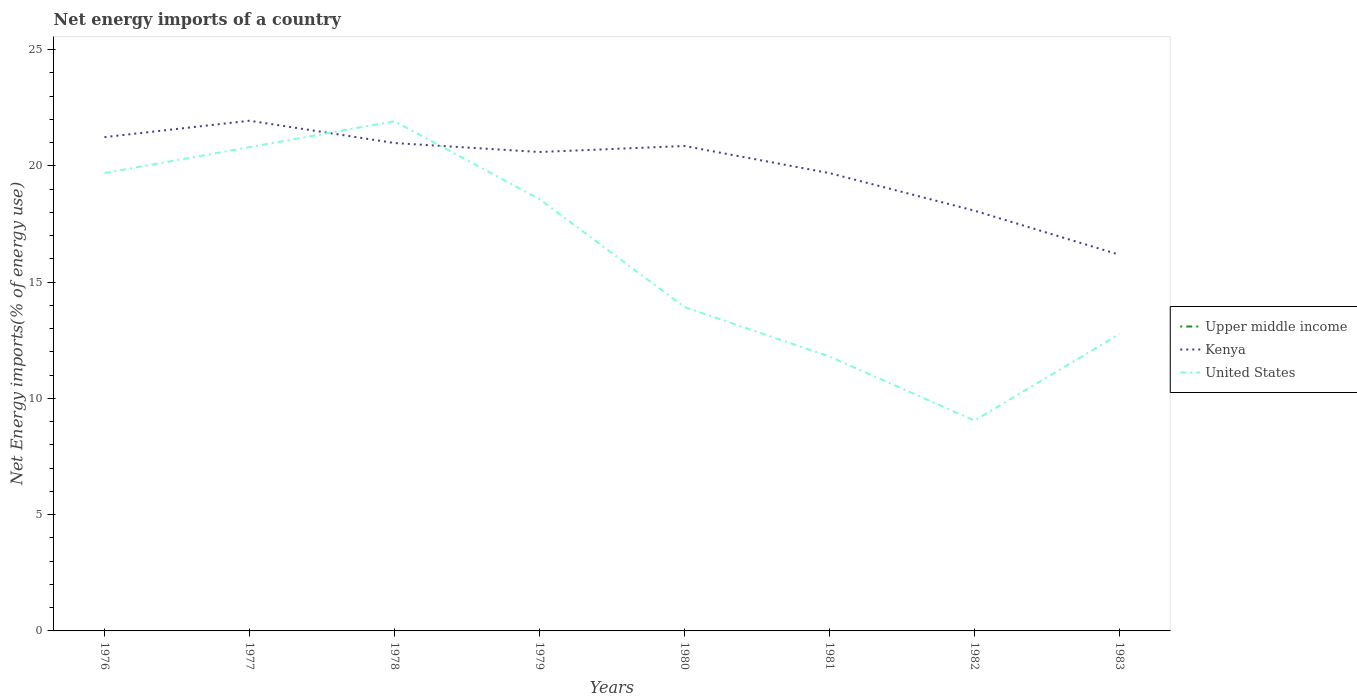Is the number of lines equal to the number of legend labels?
Provide a succinct answer. No. Across all years, what is the maximum net energy imports in United States?
Offer a terse response. 9.05. What is the total net energy imports in Kenya in the graph?
Your answer should be very brief. -0.71. What is the difference between the highest and the second highest net energy imports in United States?
Offer a very short reply. 12.87. What is the difference between the highest and the lowest net energy imports in Upper middle income?
Give a very brief answer. 0. What is the difference between two consecutive major ticks on the Y-axis?
Your response must be concise. 5. Are the values on the major ticks of Y-axis written in scientific E-notation?
Provide a short and direct response. No. Where does the legend appear in the graph?
Offer a very short reply. Center right. How are the legend labels stacked?
Ensure brevity in your answer.  Vertical. What is the title of the graph?
Your answer should be compact. Net energy imports of a country. Does "Venezuela" appear as one of the legend labels in the graph?
Your answer should be very brief. No. What is the label or title of the Y-axis?
Your response must be concise. Net Energy imports(% of energy use). What is the Net Energy imports(% of energy use) in Upper middle income in 1976?
Your answer should be compact. 0. What is the Net Energy imports(% of energy use) in Kenya in 1976?
Provide a succinct answer. 21.24. What is the Net Energy imports(% of energy use) of United States in 1976?
Keep it short and to the point. 19.69. What is the Net Energy imports(% of energy use) in Kenya in 1977?
Your answer should be very brief. 21.95. What is the Net Energy imports(% of energy use) of United States in 1977?
Make the answer very short. 20.81. What is the Net Energy imports(% of energy use) of Upper middle income in 1978?
Ensure brevity in your answer.  0. What is the Net Energy imports(% of energy use) of Kenya in 1978?
Your answer should be very brief. 20.99. What is the Net Energy imports(% of energy use) in United States in 1978?
Offer a terse response. 21.92. What is the Net Energy imports(% of energy use) in Upper middle income in 1979?
Your response must be concise. 0. What is the Net Energy imports(% of energy use) of Kenya in 1979?
Give a very brief answer. 20.6. What is the Net Energy imports(% of energy use) in United States in 1979?
Your response must be concise. 18.57. What is the Net Energy imports(% of energy use) of Kenya in 1980?
Your response must be concise. 20.86. What is the Net Energy imports(% of energy use) in United States in 1980?
Your response must be concise. 13.93. What is the Net Energy imports(% of energy use) in Kenya in 1981?
Provide a short and direct response. 19.69. What is the Net Energy imports(% of energy use) of United States in 1981?
Offer a very short reply. 11.8. What is the Net Energy imports(% of energy use) in Upper middle income in 1982?
Offer a terse response. 0. What is the Net Energy imports(% of energy use) of Kenya in 1982?
Make the answer very short. 18.08. What is the Net Energy imports(% of energy use) in United States in 1982?
Give a very brief answer. 9.05. What is the Net Energy imports(% of energy use) of Kenya in 1983?
Your answer should be very brief. 16.18. What is the Net Energy imports(% of energy use) of United States in 1983?
Offer a very short reply. 12.77. Across all years, what is the maximum Net Energy imports(% of energy use) of Kenya?
Make the answer very short. 21.95. Across all years, what is the maximum Net Energy imports(% of energy use) of United States?
Keep it short and to the point. 21.92. Across all years, what is the minimum Net Energy imports(% of energy use) in Kenya?
Ensure brevity in your answer.  16.18. Across all years, what is the minimum Net Energy imports(% of energy use) in United States?
Offer a very short reply. 9.05. What is the total Net Energy imports(% of energy use) of Kenya in the graph?
Your response must be concise. 159.58. What is the total Net Energy imports(% of energy use) of United States in the graph?
Your response must be concise. 128.55. What is the difference between the Net Energy imports(% of energy use) of Kenya in 1976 and that in 1977?
Your answer should be compact. -0.71. What is the difference between the Net Energy imports(% of energy use) of United States in 1976 and that in 1977?
Offer a terse response. -1.11. What is the difference between the Net Energy imports(% of energy use) of Kenya in 1976 and that in 1978?
Provide a short and direct response. 0.25. What is the difference between the Net Energy imports(% of energy use) of United States in 1976 and that in 1978?
Keep it short and to the point. -2.23. What is the difference between the Net Energy imports(% of energy use) in Kenya in 1976 and that in 1979?
Make the answer very short. 0.64. What is the difference between the Net Energy imports(% of energy use) in United States in 1976 and that in 1979?
Your answer should be very brief. 1.12. What is the difference between the Net Energy imports(% of energy use) in Kenya in 1976 and that in 1980?
Offer a terse response. 0.38. What is the difference between the Net Energy imports(% of energy use) in United States in 1976 and that in 1980?
Ensure brevity in your answer.  5.76. What is the difference between the Net Energy imports(% of energy use) of Kenya in 1976 and that in 1981?
Keep it short and to the point. 1.55. What is the difference between the Net Energy imports(% of energy use) in United States in 1976 and that in 1981?
Your answer should be very brief. 7.89. What is the difference between the Net Energy imports(% of energy use) of Kenya in 1976 and that in 1982?
Your answer should be compact. 3.16. What is the difference between the Net Energy imports(% of energy use) in United States in 1976 and that in 1982?
Make the answer very short. 10.65. What is the difference between the Net Energy imports(% of energy use) in Kenya in 1976 and that in 1983?
Make the answer very short. 5.06. What is the difference between the Net Energy imports(% of energy use) of United States in 1976 and that in 1983?
Provide a short and direct response. 6.92. What is the difference between the Net Energy imports(% of energy use) in Kenya in 1977 and that in 1978?
Provide a short and direct response. 0.96. What is the difference between the Net Energy imports(% of energy use) in United States in 1977 and that in 1978?
Your answer should be compact. -1.12. What is the difference between the Net Energy imports(% of energy use) of Kenya in 1977 and that in 1979?
Keep it short and to the point. 1.35. What is the difference between the Net Energy imports(% of energy use) in United States in 1977 and that in 1979?
Offer a very short reply. 2.23. What is the difference between the Net Energy imports(% of energy use) of Kenya in 1977 and that in 1980?
Provide a succinct answer. 1.09. What is the difference between the Net Energy imports(% of energy use) in United States in 1977 and that in 1980?
Your answer should be compact. 6.88. What is the difference between the Net Energy imports(% of energy use) in Kenya in 1977 and that in 1981?
Provide a succinct answer. 2.25. What is the difference between the Net Energy imports(% of energy use) of United States in 1977 and that in 1981?
Provide a short and direct response. 9.01. What is the difference between the Net Energy imports(% of energy use) in Kenya in 1977 and that in 1982?
Your answer should be very brief. 3.87. What is the difference between the Net Energy imports(% of energy use) of United States in 1977 and that in 1982?
Your answer should be compact. 11.76. What is the difference between the Net Energy imports(% of energy use) of Kenya in 1977 and that in 1983?
Provide a succinct answer. 5.76. What is the difference between the Net Energy imports(% of energy use) of United States in 1977 and that in 1983?
Your answer should be very brief. 8.04. What is the difference between the Net Energy imports(% of energy use) of Kenya in 1978 and that in 1979?
Offer a very short reply. 0.39. What is the difference between the Net Energy imports(% of energy use) in United States in 1978 and that in 1979?
Provide a succinct answer. 3.35. What is the difference between the Net Energy imports(% of energy use) in Kenya in 1978 and that in 1980?
Your answer should be compact. 0.13. What is the difference between the Net Energy imports(% of energy use) of United States in 1978 and that in 1980?
Offer a very short reply. 7.99. What is the difference between the Net Energy imports(% of energy use) of Kenya in 1978 and that in 1981?
Offer a very short reply. 1.29. What is the difference between the Net Energy imports(% of energy use) of United States in 1978 and that in 1981?
Your answer should be very brief. 10.12. What is the difference between the Net Energy imports(% of energy use) of Kenya in 1978 and that in 1982?
Your answer should be very brief. 2.91. What is the difference between the Net Energy imports(% of energy use) of United States in 1978 and that in 1982?
Your answer should be very brief. 12.87. What is the difference between the Net Energy imports(% of energy use) in Kenya in 1978 and that in 1983?
Make the answer very short. 4.81. What is the difference between the Net Energy imports(% of energy use) of United States in 1978 and that in 1983?
Keep it short and to the point. 9.15. What is the difference between the Net Energy imports(% of energy use) in Kenya in 1979 and that in 1980?
Your answer should be compact. -0.26. What is the difference between the Net Energy imports(% of energy use) in United States in 1979 and that in 1980?
Keep it short and to the point. 4.64. What is the difference between the Net Energy imports(% of energy use) of Kenya in 1979 and that in 1981?
Your answer should be compact. 0.91. What is the difference between the Net Energy imports(% of energy use) of United States in 1979 and that in 1981?
Offer a very short reply. 6.77. What is the difference between the Net Energy imports(% of energy use) of Kenya in 1979 and that in 1982?
Your answer should be compact. 2.52. What is the difference between the Net Energy imports(% of energy use) in United States in 1979 and that in 1982?
Your answer should be very brief. 9.53. What is the difference between the Net Energy imports(% of energy use) of Kenya in 1979 and that in 1983?
Keep it short and to the point. 4.42. What is the difference between the Net Energy imports(% of energy use) in United States in 1979 and that in 1983?
Offer a terse response. 5.8. What is the difference between the Net Energy imports(% of energy use) of Kenya in 1980 and that in 1981?
Offer a very short reply. 1.17. What is the difference between the Net Energy imports(% of energy use) in United States in 1980 and that in 1981?
Provide a short and direct response. 2.13. What is the difference between the Net Energy imports(% of energy use) in Kenya in 1980 and that in 1982?
Make the answer very short. 2.78. What is the difference between the Net Energy imports(% of energy use) in United States in 1980 and that in 1982?
Offer a very short reply. 4.88. What is the difference between the Net Energy imports(% of energy use) of Kenya in 1980 and that in 1983?
Your answer should be very brief. 4.68. What is the difference between the Net Energy imports(% of energy use) in United States in 1980 and that in 1983?
Provide a short and direct response. 1.16. What is the difference between the Net Energy imports(% of energy use) of Kenya in 1981 and that in 1982?
Keep it short and to the point. 1.62. What is the difference between the Net Energy imports(% of energy use) in United States in 1981 and that in 1982?
Make the answer very short. 2.75. What is the difference between the Net Energy imports(% of energy use) in Kenya in 1981 and that in 1983?
Offer a very short reply. 3.51. What is the difference between the Net Energy imports(% of energy use) in United States in 1981 and that in 1983?
Your answer should be compact. -0.97. What is the difference between the Net Energy imports(% of energy use) of Kenya in 1982 and that in 1983?
Keep it short and to the point. 1.9. What is the difference between the Net Energy imports(% of energy use) of United States in 1982 and that in 1983?
Keep it short and to the point. -3.72. What is the difference between the Net Energy imports(% of energy use) of Kenya in 1976 and the Net Energy imports(% of energy use) of United States in 1977?
Your answer should be compact. 0.43. What is the difference between the Net Energy imports(% of energy use) of Kenya in 1976 and the Net Energy imports(% of energy use) of United States in 1978?
Provide a short and direct response. -0.68. What is the difference between the Net Energy imports(% of energy use) of Kenya in 1976 and the Net Energy imports(% of energy use) of United States in 1979?
Give a very brief answer. 2.67. What is the difference between the Net Energy imports(% of energy use) of Kenya in 1976 and the Net Energy imports(% of energy use) of United States in 1980?
Your response must be concise. 7.31. What is the difference between the Net Energy imports(% of energy use) of Kenya in 1976 and the Net Energy imports(% of energy use) of United States in 1981?
Keep it short and to the point. 9.44. What is the difference between the Net Energy imports(% of energy use) in Kenya in 1976 and the Net Energy imports(% of energy use) in United States in 1982?
Provide a succinct answer. 12.19. What is the difference between the Net Energy imports(% of energy use) of Kenya in 1976 and the Net Energy imports(% of energy use) of United States in 1983?
Your answer should be very brief. 8.47. What is the difference between the Net Energy imports(% of energy use) of Kenya in 1977 and the Net Energy imports(% of energy use) of United States in 1978?
Ensure brevity in your answer.  0.02. What is the difference between the Net Energy imports(% of energy use) of Kenya in 1977 and the Net Energy imports(% of energy use) of United States in 1979?
Offer a very short reply. 3.37. What is the difference between the Net Energy imports(% of energy use) of Kenya in 1977 and the Net Energy imports(% of energy use) of United States in 1980?
Give a very brief answer. 8.01. What is the difference between the Net Energy imports(% of energy use) of Kenya in 1977 and the Net Energy imports(% of energy use) of United States in 1981?
Offer a very short reply. 10.14. What is the difference between the Net Energy imports(% of energy use) of Kenya in 1977 and the Net Energy imports(% of energy use) of United States in 1982?
Offer a very short reply. 12.9. What is the difference between the Net Energy imports(% of energy use) of Kenya in 1977 and the Net Energy imports(% of energy use) of United States in 1983?
Make the answer very short. 9.17. What is the difference between the Net Energy imports(% of energy use) in Kenya in 1978 and the Net Energy imports(% of energy use) in United States in 1979?
Give a very brief answer. 2.41. What is the difference between the Net Energy imports(% of energy use) in Kenya in 1978 and the Net Energy imports(% of energy use) in United States in 1980?
Your response must be concise. 7.05. What is the difference between the Net Energy imports(% of energy use) in Kenya in 1978 and the Net Energy imports(% of energy use) in United States in 1981?
Ensure brevity in your answer.  9.18. What is the difference between the Net Energy imports(% of energy use) of Kenya in 1978 and the Net Energy imports(% of energy use) of United States in 1982?
Your answer should be very brief. 11.94. What is the difference between the Net Energy imports(% of energy use) of Kenya in 1978 and the Net Energy imports(% of energy use) of United States in 1983?
Give a very brief answer. 8.22. What is the difference between the Net Energy imports(% of energy use) in Kenya in 1979 and the Net Energy imports(% of energy use) in United States in 1980?
Your response must be concise. 6.67. What is the difference between the Net Energy imports(% of energy use) in Kenya in 1979 and the Net Energy imports(% of energy use) in United States in 1981?
Make the answer very short. 8.8. What is the difference between the Net Energy imports(% of energy use) of Kenya in 1979 and the Net Energy imports(% of energy use) of United States in 1982?
Provide a short and direct response. 11.55. What is the difference between the Net Energy imports(% of energy use) in Kenya in 1979 and the Net Energy imports(% of energy use) in United States in 1983?
Ensure brevity in your answer.  7.83. What is the difference between the Net Energy imports(% of energy use) in Kenya in 1980 and the Net Energy imports(% of energy use) in United States in 1981?
Your answer should be compact. 9.06. What is the difference between the Net Energy imports(% of energy use) of Kenya in 1980 and the Net Energy imports(% of energy use) of United States in 1982?
Ensure brevity in your answer.  11.81. What is the difference between the Net Energy imports(% of energy use) in Kenya in 1980 and the Net Energy imports(% of energy use) in United States in 1983?
Provide a short and direct response. 8.09. What is the difference between the Net Energy imports(% of energy use) in Kenya in 1981 and the Net Energy imports(% of energy use) in United States in 1982?
Keep it short and to the point. 10.64. What is the difference between the Net Energy imports(% of energy use) in Kenya in 1981 and the Net Energy imports(% of energy use) in United States in 1983?
Give a very brief answer. 6.92. What is the difference between the Net Energy imports(% of energy use) of Kenya in 1982 and the Net Energy imports(% of energy use) of United States in 1983?
Your answer should be very brief. 5.31. What is the average Net Energy imports(% of energy use) of Upper middle income per year?
Keep it short and to the point. 0. What is the average Net Energy imports(% of energy use) of Kenya per year?
Your answer should be very brief. 19.95. What is the average Net Energy imports(% of energy use) of United States per year?
Provide a succinct answer. 16.07. In the year 1976, what is the difference between the Net Energy imports(% of energy use) in Kenya and Net Energy imports(% of energy use) in United States?
Make the answer very short. 1.55. In the year 1977, what is the difference between the Net Energy imports(% of energy use) in Kenya and Net Energy imports(% of energy use) in United States?
Your response must be concise. 1.14. In the year 1978, what is the difference between the Net Energy imports(% of energy use) of Kenya and Net Energy imports(% of energy use) of United States?
Provide a succinct answer. -0.94. In the year 1979, what is the difference between the Net Energy imports(% of energy use) in Kenya and Net Energy imports(% of energy use) in United States?
Keep it short and to the point. 2.03. In the year 1980, what is the difference between the Net Energy imports(% of energy use) of Kenya and Net Energy imports(% of energy use) of United States?
Offer a very short reply. 6.93. In the year 1981, what is the difference between the Net Energy imports(% of energy use) of Kenya and Net Energy imports(% of energy use) of United States?
Make the answer very short. 7.89. In the year 1982, what is the difference between the Net Energy imports(% of energy use) of Kenya and Net Energy imports(% of energy use) of United States?
Provide a succinct answer. 9.03. In the year 1983, what is the difference between the Net Energy imports(% of energy use) of Kenya and Net Energy imports(% of energy use) of United States?
Give a very brief answer. 3.41. What is the ratio of the Net Energy imports(% of energy use) in Kenya in 1976 to that in 1977?
Offer a very short reply. 0.97. What is the ratio of the Net Energy imports(% of energy use) of United States in 1976 to that in 1977?
Provide a succinct answer. 0.95. What is the ratio of the Net Energy imports(% of energy use) of Kenya in 1976 to that in 1978?
Provide a short and direct response. 1.01. What is the ratio of the Net Energy imports(% of energy use) of United States in 1976 to that in 1978?
Ensure brevity in your answer.  0.9. What is the ratio of the Net Energy imports(% of energy use) in Kenya in 1976 to that in 1979?
Offer a terse response. 1.03. What is the ratio of the Net Energy imports(% of energy use) of United States in 1976 to that in 1979?
Keep it short and to the point. 1.06. What is the ratio of the Net Energy imports(% of energy use) in Kenya in 1976 to that in 1980?
Your answer should be very brief. 1.02. What is the ratio of the Net Energy imports(% of energy use) of United States in 1976 to that in 1980?
Keep it short and to the point. 1.41. What is the ratio of the Net Energy imports(% of energy use) of Kenya in 1976 to that in 1981?
Your answer should be compact. 1.08. What is the ratio of the Net Energy imports(% of energy use) of United States in 1976 to that in 1981?
Provide a succinct answer. 1.67. What is the ratio of the Net Energy imports(% of energy use) of Kenya in 1976 to that in 1982?
Make the answer very short. 1.18. What is the ratio of the Net Energy imports(% of energy use) of United States in 1976 to that in 1982?
Make the answer very short. 2.18. What is the ratio of the Net Energy imports(% of energy use) of Kenya in 1976 to that in 1983?
Provide a short and direct response. 1.31. What is the ratio of the Net Energy imports(% of energy use) in United States in 1976 to that in 1983?
Keep it short and to the point. 1.54. What is the ratio of the Net Energy imports(% of energy use) of Kenya in 1977 to that in 1978?
Keep it short and to the point. 1.05. What is the ratio of the Net Energy imports(% of energy use) of United States in 1977 to that in 1978?
Provide a short and direct response. 0.95. What is the ratio of the Net Energy imports(% of energy use) of Kenya in 1977 to that in 1979?
Your answer should be compact. 1.07. What is the ratio of the Net Energy imports(% of energy use) in United States in 1977 to that in 1979?
Keep it short and to the point. 1.12. What is the ratio of the Net Energy imports(% of energy use) of Kenya in 1977 to that in 1980?
Make the answer very short. 1.05. What is the ratio of the Net Energy imports(% of energy use) in United States in 1977 to that in 1980?
Make the answer very short. 1.49. What is the ratio of the Net Energy imports(% of energy use) in Kenya in 1977 to that in 1981?
Make the answer very short. 1.11. What is the ratio of the Net Energy imports(% of energy use) of United States in 1977 to that in 1981?
Ensure brevity in your answer.  1.76. What is the ratio of the Net Energy imports(% of energy use) in Kenya in 1977 to that in 1982?
Make the answer very short. 1.21. What is the ratio of the Net Energy imports(% of energy use) of United States in 1977 to that in 1982?
Your response must be concise. 2.3. What is the ratio of the Net Energy imports(% of energy use) in Kenya in 1977 to that in 1983?
Your response must be concise. 1.36. What is the ratio of the Net Energy imports(% of energy use) of United States in 1977 to that in 1983?
Provide a short and direct response. 1.63. What is the ratio of the Net Energy imports(% of energy use) in Kenya in 1978 to that in 1979?
Keep it short and to the point. 1.02. What is the ratio of the Net Energy imports(% of energy use) in United States in 1978 to that in 1979?
Keep it short and to the point. 1.18. What is the ratio of the Net Energy imports(% of energy use) in Kenya in 1978 to that in 1980?
Your answer should be compact. 1.01. What is the ratio of the Net Energy imports(% of energy use) of United States in 1978 to that in 1980?
Offer a terse response. 1.57. What is the ratio of the Net Energy imports(% of energy use) in Kenya in 1978 to that in 1981?
Your response must be concise. 1.07. What is the ratio of the Net Energy imports(% of energy use) of United States in 1978 to that in 1981?
Provide a short and direct response. 1.86. What is the ratio of the Net Energy imports(% of energy use) in Kenya in 1978 to that in 1982?
Give a very brief answer. 1.16. What is the ratio of the Net Energy imports(% of energy use) of United States in 1978 to that in 1982?
Your answer should be compact. 2.42. What is the ratio of the Net Energy imports(% of energy use) of Kenya in 1978 to that in 1983?
Offer a very short reply. 1.3. What is the ratio of the Net Energy imports(% of energy use) in United States in 1978 to that in 1983?
Keep it short and to the point. 1.72. What is the ratio of the Net Energy imports(% of energy use) of Kenya in 1979 to that in 1980?
Your response must be concise. 0.99. What is the ratio of the Net Energy imports(% of energy use) in United States in 1979 to that in 1980?
Provide a succinct answer. 1.33. What is the ratio of the Net Energy imports(% of energy use) in Kenya in 1979 to that in 1981?
Keep it short and to the point. 1.05. What is the ratio of the Net Energy imports(% of energy use) of United States in 1979 to that in 1981?
Your answer should be very brief. 1.57. What is the ratio of the Net Energy imports(% of energy use) in Kenya in 1979 to that in 1982?
Make the answer very short. 1.14. What is the ratio of the Net Energy imports(% of energy use) of United States in 1979 to that in 1982?
Make the answer very short. 2.05. What is the ratio of the Net Energy imports(% of energy use) in Kenya in 1979 to that in 1983?
Provide a succinct answer. 1.27. What is the ratio of the Net Energy imports(% of energy use) of United States in 1979 to that in 1983?
Give a very brief answer. 1.45. What is the ratio of the Net Energy imports(% of energy use) of Kenya in 1980 to that in 1981?
Keep it short and to the point. 1.06. What is the ratio of the Net Energy imports(% of energy use) of United States in 1980 to that in 1981?
Offer a terse response. 1.18. What is the ratio of the Net Energy imports(% of energy use) of Kenya in 1980 to that in 1982?
Your answer should be very brief. 1.15. What is the ratio of the Net Energy imports(% of energy use) in United States in 1980 to that in 1982?
Offer a terse response. 1.54. What is the ratio of the Net Energy imports(% of energy use) in Kenya in 1980 to that in 1983?
Provide a succinct answer. 1.29. What is the ratio of the Net Energy imports(% of energy use) of Kenya in 1981 to that in 1982?
Make the answer very short. 1.09. What is the ratio of the Net Energy imports(% of energy use) of United States in 1981 to that in 1982?
Give a very brief answer. 1.3. What is the ratio of the Net Energy imports(% of energy use) in Kenya in 1981 to that in 1983?
Provide a short and direct response. 1.22. What is the ratio of the Net Energy imports(% of energy use) in United States in 1981 to that in 1983?
Make the answer very short. 0.92. What is the ratio of the Net Energy imports(% of energy use) of Kenya in 1982 to that in 1983?
Your response must be concise. 1.12. What is the ratio of the Net Energy imports(% of energy use) in United States in 1982 to that in 1983?
Provide a short and direct response. 0.71. What is the difference between the highest and the second highest Net Energy imports(% of energy use) of Kenya?
Ensure brevity in your answer.  0.71. What is the difference between the highest and the second highest Net Energy imports(% of energy use) in United States?
Make the answer very short. 1.12. What is the difference between the highest and the lowest Net Energy imports(% of energy use) of Kenya?
Give a very brief answer. 5.76. What is the difference between the highest and the lowest Net Energy imports(% of energy use) of United States?
Provide a short and direct response. 12.87. 